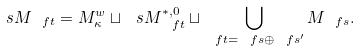<formula> <loc_0><loc_0><loc_500><loc_500>\ s M _ { \ f t } = M _ { \kappa } ^ { w } \sqcup \ s M _ { \ f t } ^ { * , 0 } \sqcup \bigcup _ { \ f t = \ f s \oplus \ f s ^ { \prime } } M _ { \ f s } .</formula> 